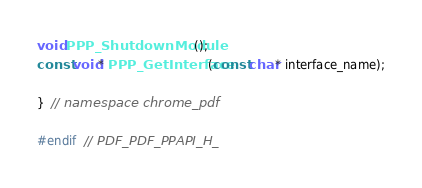<code> <loc_0><loc_0><loc_500><loc_500><_C_>void PPP_ShutdownModule();
const void* PPP_GetInterface(const char* interface_name);

}  // namespace chrome_pdf

#endif  // PDF_PDF_PPAPI_H_
</code> 